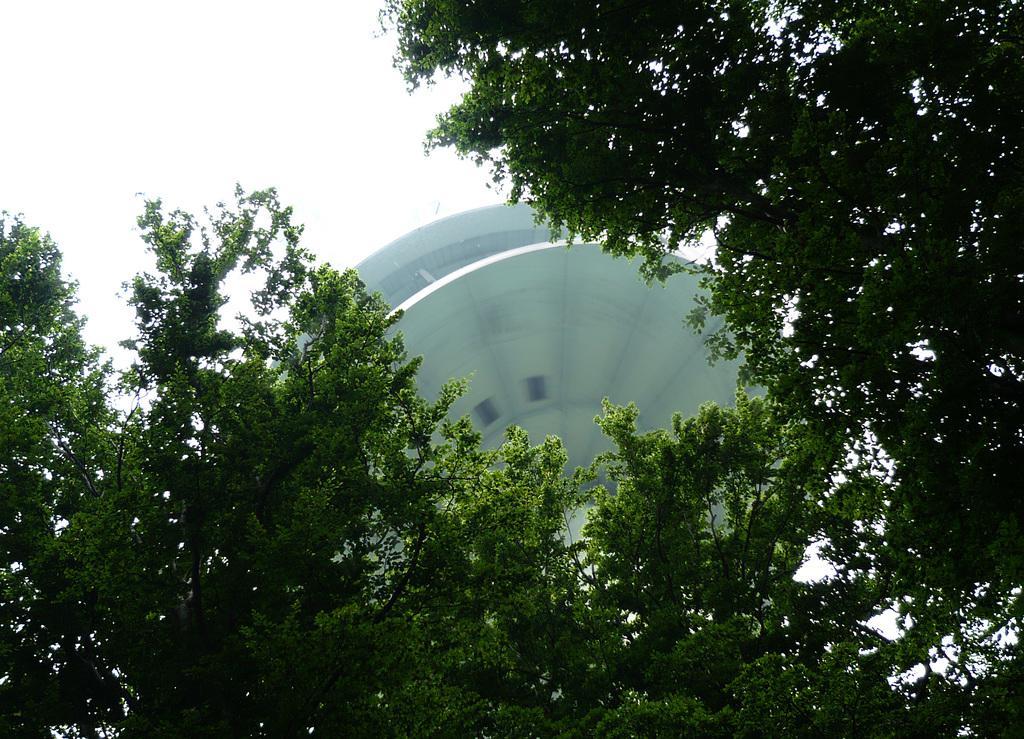Describe this image in one or two sentences. At the bottom of this image, there are trees having green color leaves. On the right side, there are branches of the trees having green color leaves. In the background, there is an object and there are clouds in the sky. 